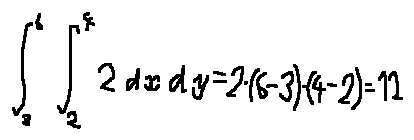Convert formula to latex. <formula><loc_0><loc_0><loc_500><loc_500>\int \lim i t s _ { 3 } ^ { 6 } \int \lim i t s _ { 2 } ^ { 4 } 2 d x d y = 2 \cdot ( 6 - 3 ) \cdot ( 4 - 2 ) = 1 2</formula> 